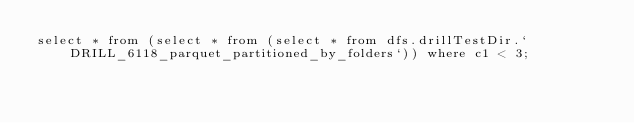<code> <loc_0><loc_0><loc_500><loc_500><_SQL_>select * from (select * from (select * from dfs.drillTestDir.`DRILL_6118_parquet_partitioned_by_folders`)) where c1 < 3;</code> 